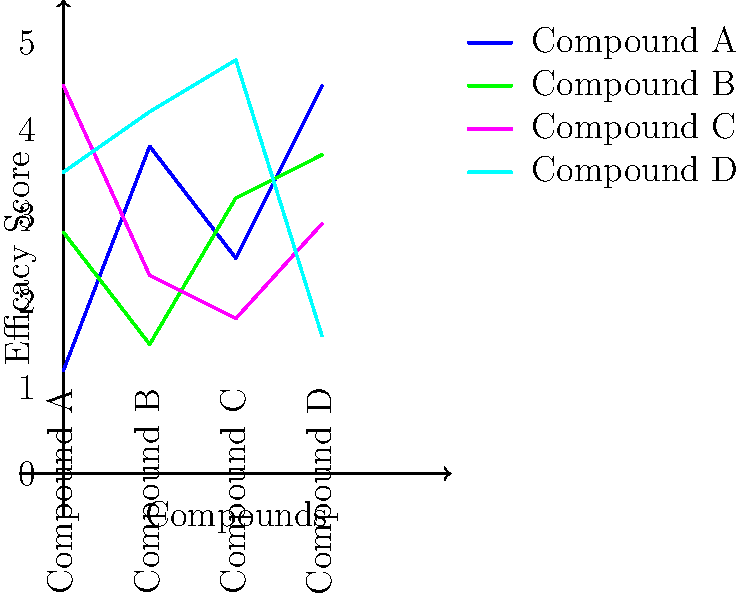Based on the parallel coordinate plot comparing the efficacy of four psychoactive compounds (A, B, C, and D) across four different measures, which compound demonstrates the highest overall efficacy and consistency across all measures? To determine the compound with the highest overall efficacy and consistency, we need to analyze the plot for each compound:

1. Compound A (Red line):
   - Starts low (1.2), peaks at the third measure (4.5), and ends high (4.5)
   - Shows high variability across measures

2. Compound B (Green line):
   - Starts moderately (2.8), dips in the middle (1.5), and ends relatively high (3.7)
   - Shows moderate variability

3. Compound C (Blue line):
   - Starts high (4.5), dips in the middle (1.8), and ends moderately (2.9)
   - Shows high variability

4. Compound D (Purple line):
   - Starts moderately high (3.5), maintains high values (4.2, 4.8), and ends low (1.6)
   - Shows the least variability for the first three measures, but drops significantly in the last measure

Compound D demonstrates the highest overall efficacy for three out of four measures and shows the most consistency across the first three measures. Although it drops in the last measure, its performance in the other three measures is superior to the other compounds.
Answer: Compound D 